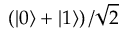Convert formula to latex. <formula><loc_0><loc_0><loc_500><loc_500>\left ( \left | 0 \right \rangle + \left | 1 \right \rangle \right ) / { \sqrt { 2 } }</formula> 